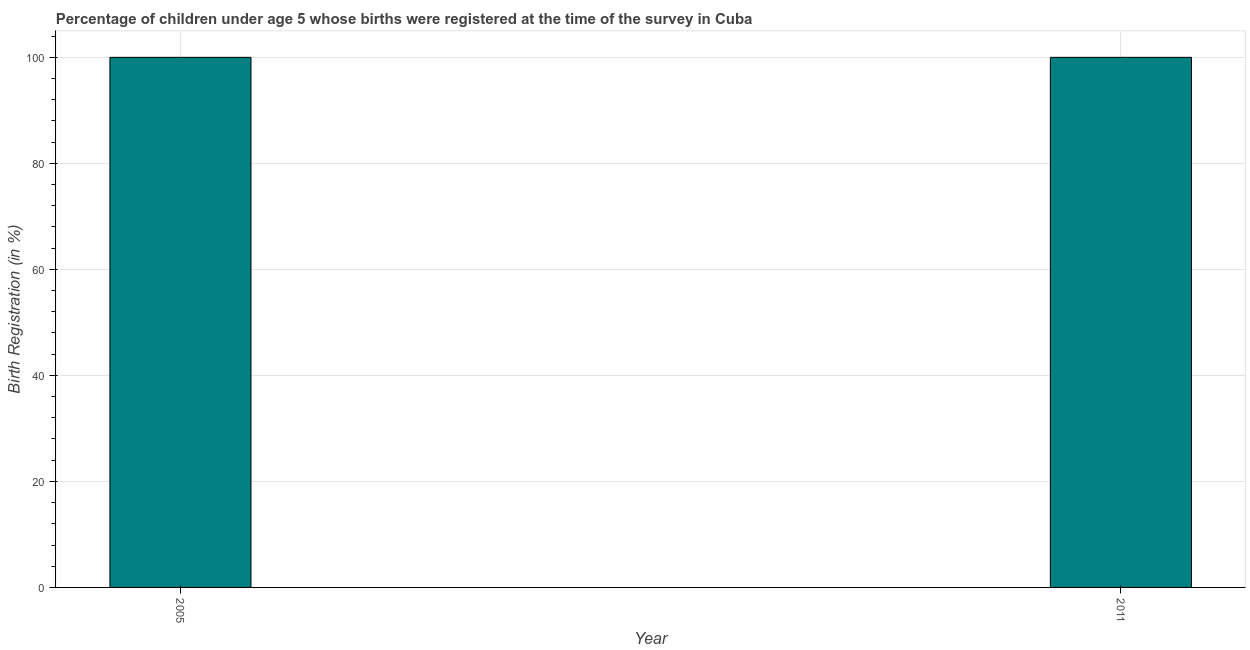Does the graph contain any zero values?
Your answer should be compact. No. Does the graph contain grids?
Provide a short and direct response. Yes. What is the title of the graph?
Offer a terse response. Percentage of children under age 5 whose births were registered at the time of the survey in Cuba. What is the label or title of the Y-axis?
Make the answer very short. Birth Registration (in %). What is the birth registration in 2011?
Your answer should be compact. 100. Across all years, what is the minimum birth registration?
Your response must be concise. 100. In which year was the birth registration minimum?
Your answer should be compact. 2005. What is the difference between the birth registration in 2005 and 2011?
Provide a succinct answer. 0. In how many years, is the birth registration greater than 16 %?
Give a very brief answer. 2. What is the ratio of the birth registration in 2005 to that in 2011?
Give a very brief answer. 1. Is the birth registration in 2005 less than that in 2011?
Provide a succinct answer. No. In how many years, is the birth registration greater than the average birth registration taken over all years?
Your answer should be very brief. 0. How many bars are there?
Ensure brevity in your answer.  2. Are all the bars in the graph horizontal?
Offer a terse response. No. How many years are there in the graph?
Provide a succinct answer. 2. What is the Birth Registration (in %) in 2011?
Offer a very short reply. 100. 